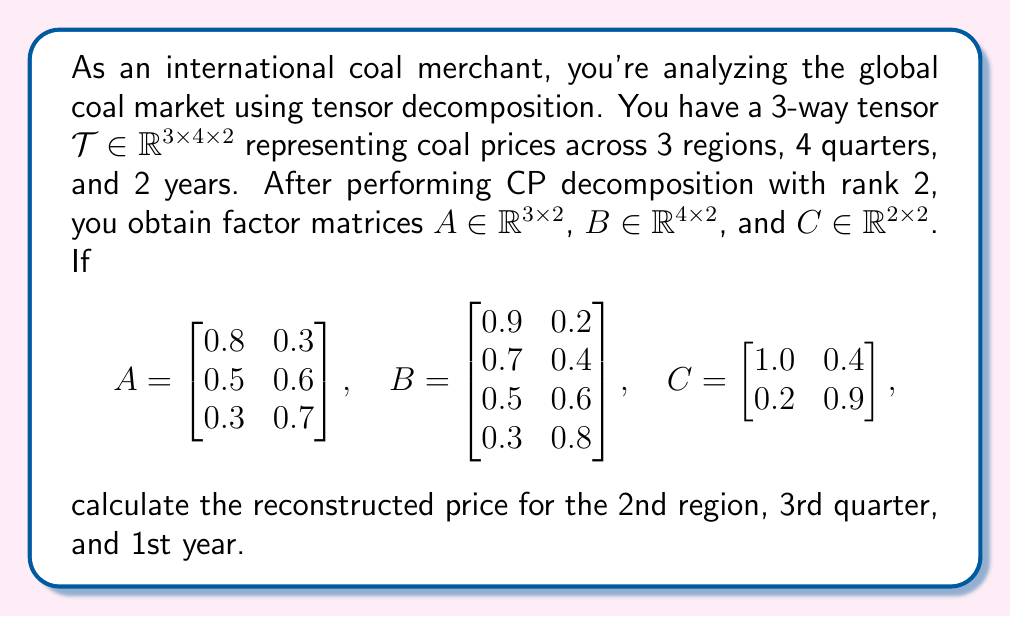Provide a solution to this math problem. To solve this problem, we'll use the CP decomposition formula and the given factor matrices. The steps are as follows:

1) The CP decomposition approximates the tensor $\mathcal{T}$ as:

   $$\mathcal{T} \approx \sum_{r=1}^R a_r \circ b_r \circ c_r$$

   where $R$ is the rank (in this case, 2), and $a_r$, $b_r$, and $c_r$ are columns of the factor matrices $A$, $B$, and $C$ respectively.

2) For a specific element $(i,j,k)$ of the reconstructed tensor, we can calculate its value using:

   $$t_{ijk} \approx \sum_{r=1}^R a_{ir} b_{jr} c_{kr}$$

3) We need to calculate the price for the 2nd region (i=2), 3rd quarter (j=3), and 1st year (k=1). Let's extract the relevant values from the factor matrices:

   From $A$: $a_{21} = 0.5$, $a_{22} = 0.6$
   From $B$: $b_{31} = 0.5$, $b_{32} = 0.6$
   From $C$: $c_{11} = 1.0$, $c_{12} = 0.4$

4) Now, let's apply the formula:

   $$t_{231} \approx (a_{21} \times b_{31} \times c_{11}) + (a_{22} \times b_{32} \times c_{12})$$

5) Substituting the values:

   $$t_{231} \approx (0.5 \times 0.5 \times 1.0) + (0.6 \times 0.6 \times 0.4)$$

6) Calculating:

   $$t_{231} \approx 0.25 + 0.144 = 0.394$$

Therefore, the reconstructed price for the 2nd region, 3rd quarter, and 1st year is approximately 0.394.
Answer: 0.394 